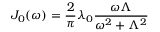Convert formula to latex. <formula><loc_0><loc_0><loc_500><loc_500>J _ { 0 } ( \omega ) = \frac { 2 } { \pi } \lambda _ { 0 } \frac { \omega \Lambda } { \omega ^ { 2 } + \Lambda ^ { 2 } }</formula> 